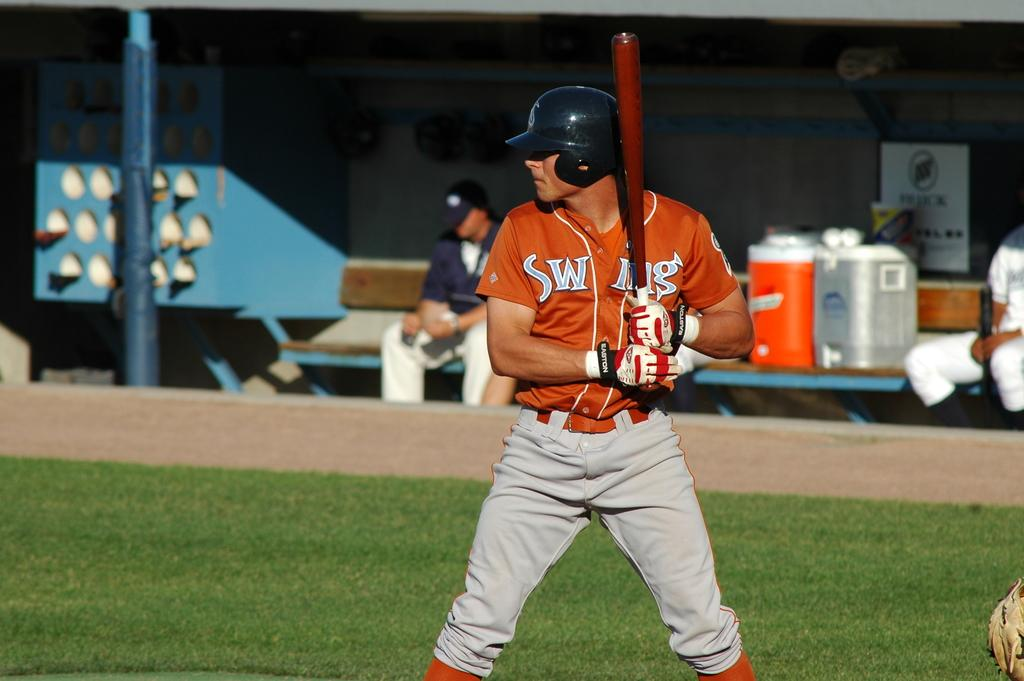<image>
Share a concise interpretation of the image provided. Man wearing an orange jersey with the letters SW on it getting ready to bat. 